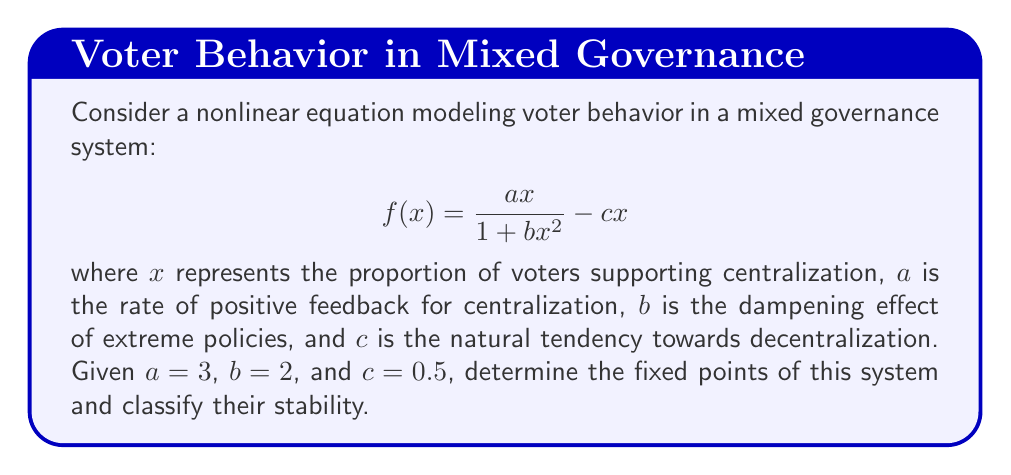Show me your answer to this math problem. To find the fixed points, we set $f(x) = x$:

1) $\frac{3x}{1 + 2x^2} - 0.5x = x$

2) Simplify: $\frac{3x}{1 + 2x^2} = 1.5x$

3) Multiply both sides by $(1 + 2x^2)$:
   $3x = 1.5x(1 + 2x^2)$
   $3x = 1.5x + 3x^3$

4) Rearrange: $3x^3 - 1.5x + 3x = 0$
              $3x^3 + 1.5x = 0$
              $3x(x^2 + 0.5) = 0$

5) Solve:
   $x = 0$ or $x^2 + 0.5 = 0$
   $x = 0$ or $x = \pm i\sqrt{0.5}$

6) The only real fixed point is $x = 0$.

To classify stability, we evaluate $f'(x)$ at $x = 0$:

7) $f'(x) = \frac{3(1 + 2x^2) - 6x^2}{(1 + 2x^2)^2} - 0.5$

8) $f'(0) = 3 - 0.5 = 2.5$

9) Since $|f'(0)| > 1$, the fixed point at $x = 0$ is unstable.
Answer: One unstable fixed point at $x = 0$. 